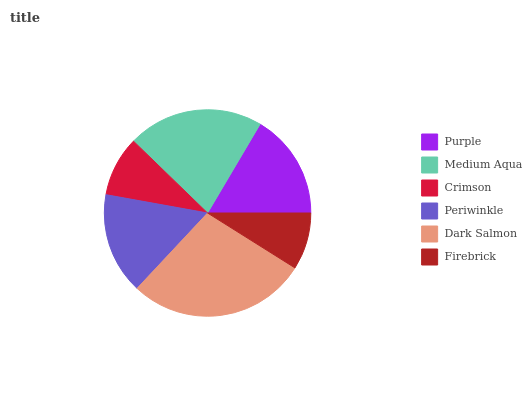Is Firebrick the minimum?
Answer yes or no. Yes. Is Dark Salmon the maximum?
Answer yes or no. Yes. Is Medium Aqua the minimum?
Answer yes or no. No. Is Medium Aqua the maximum?
Answer yes or no. No. Is Medium Aqua greater than Purple?
Answer yes or no. Yes. Is Purple less than Medium Aqua?
Answer yes or no. Yes. Is Purple greater than Medium Aqua?
Answer yes or no. No. Is Medium Aqua less than Purple?
Answer yes or no. No. Is Purple the high median?
Answer yes or no. Yes. Is Periwinkle the low median?
Answer yes or no. Yes. Is Crimson the high median?
Answer yes or no. No. Is Dark Salmon the low median?
Answer yes or no. No. 